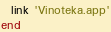<code> <loc_0><loc_0><loc_500><loc_500><_Ruby_>  link 'Vinoteka.app'
end
</code> 